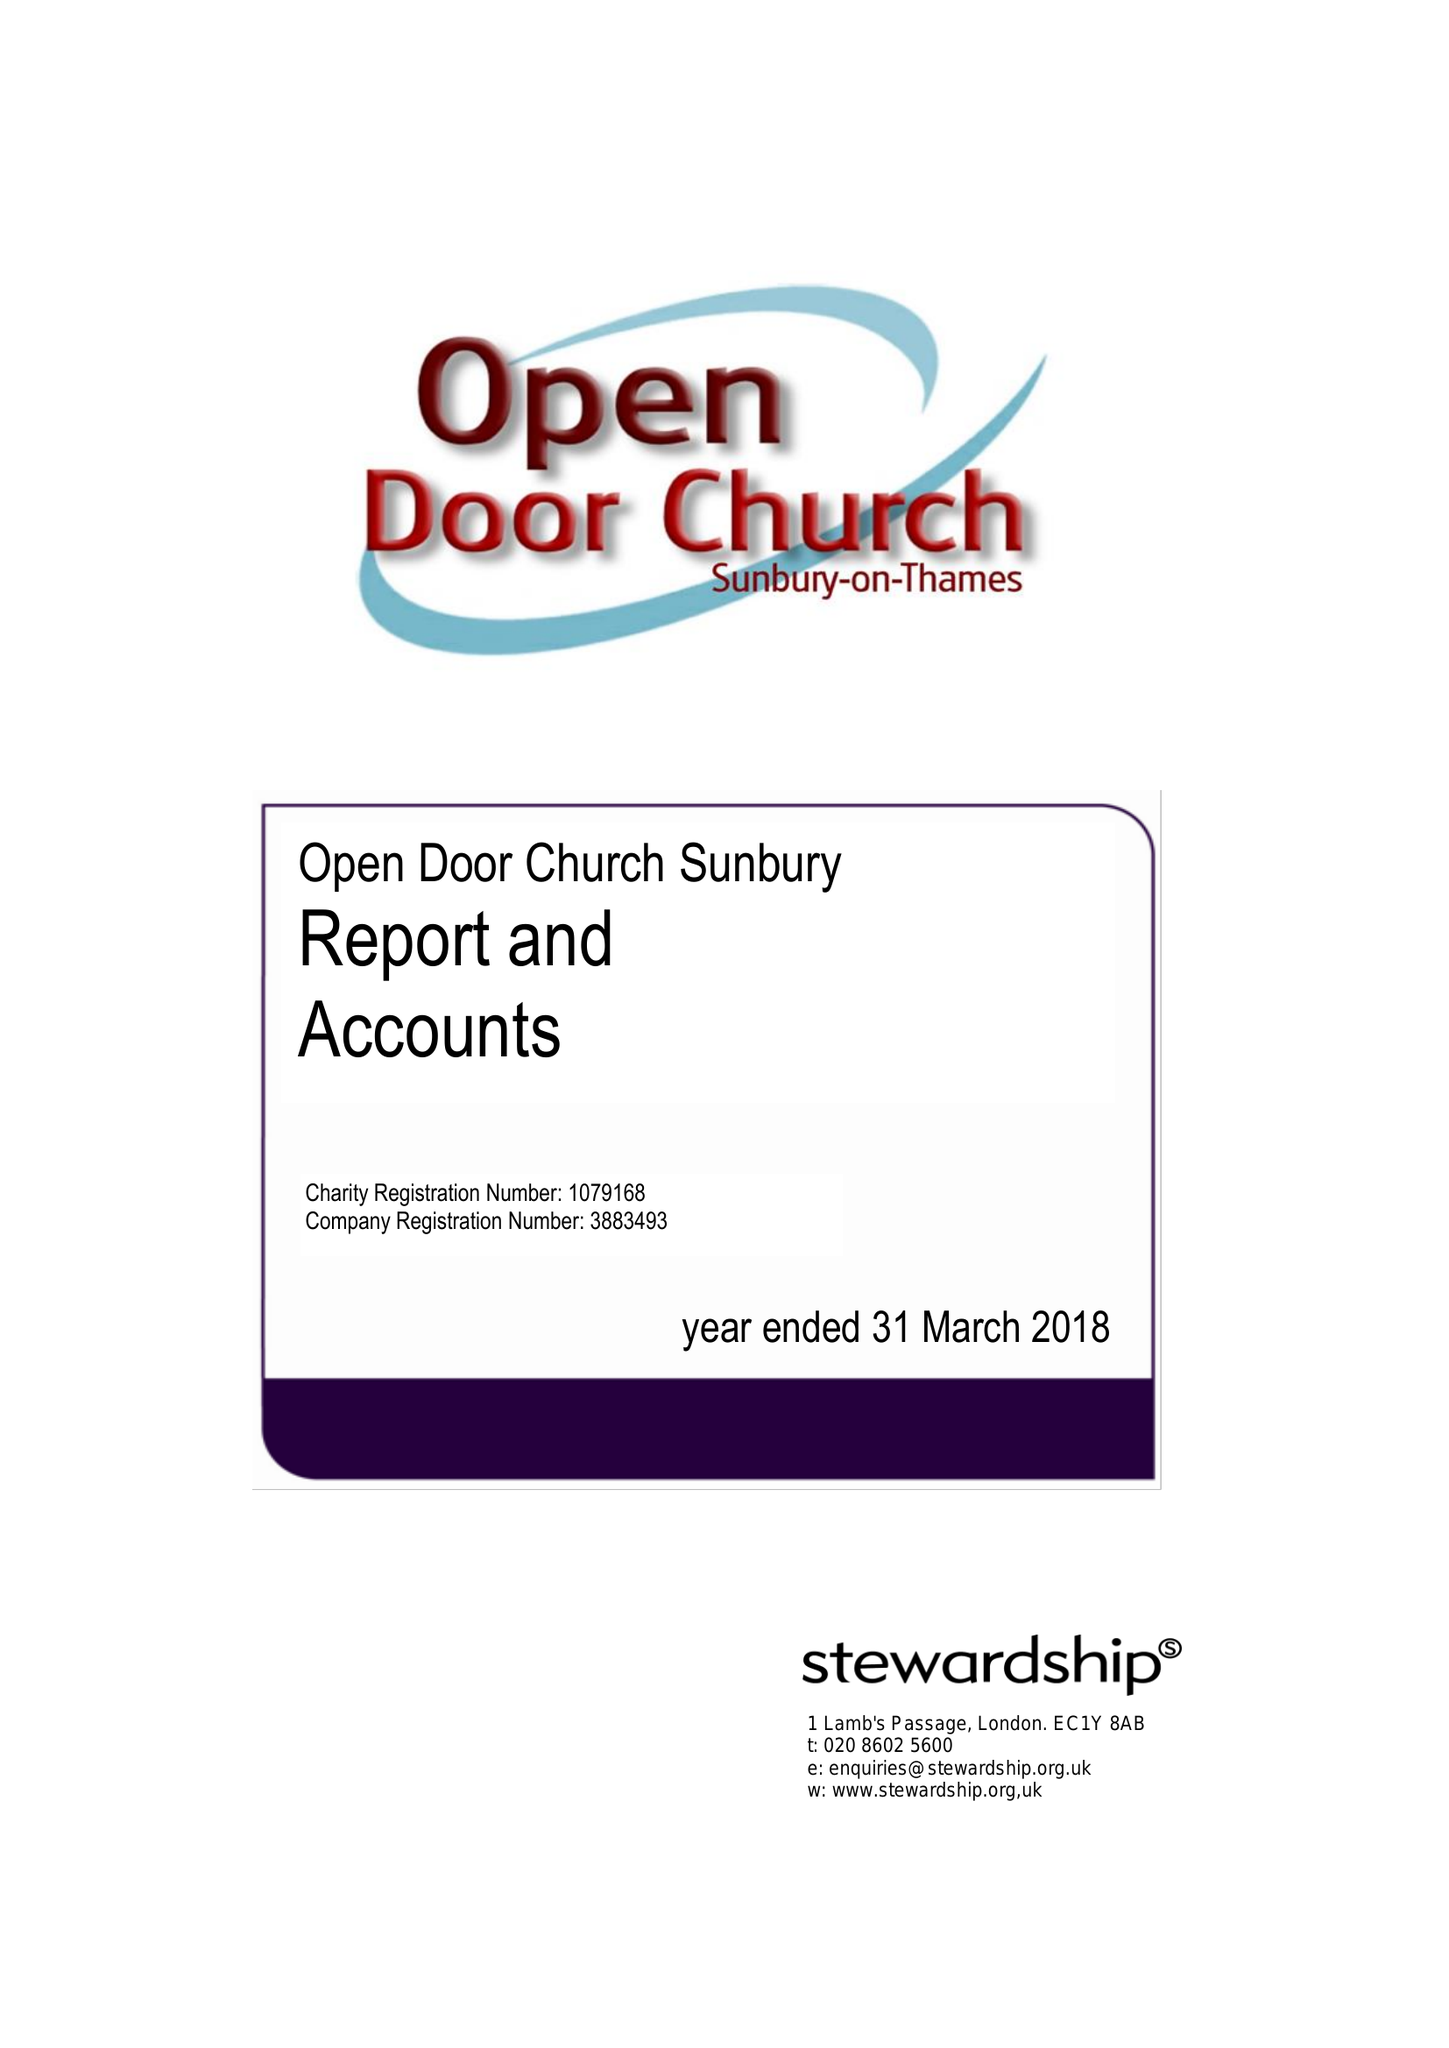What is the value for the income_annually_in_british_pounds?
Answer the question using a single word or phrase. 138922.00 